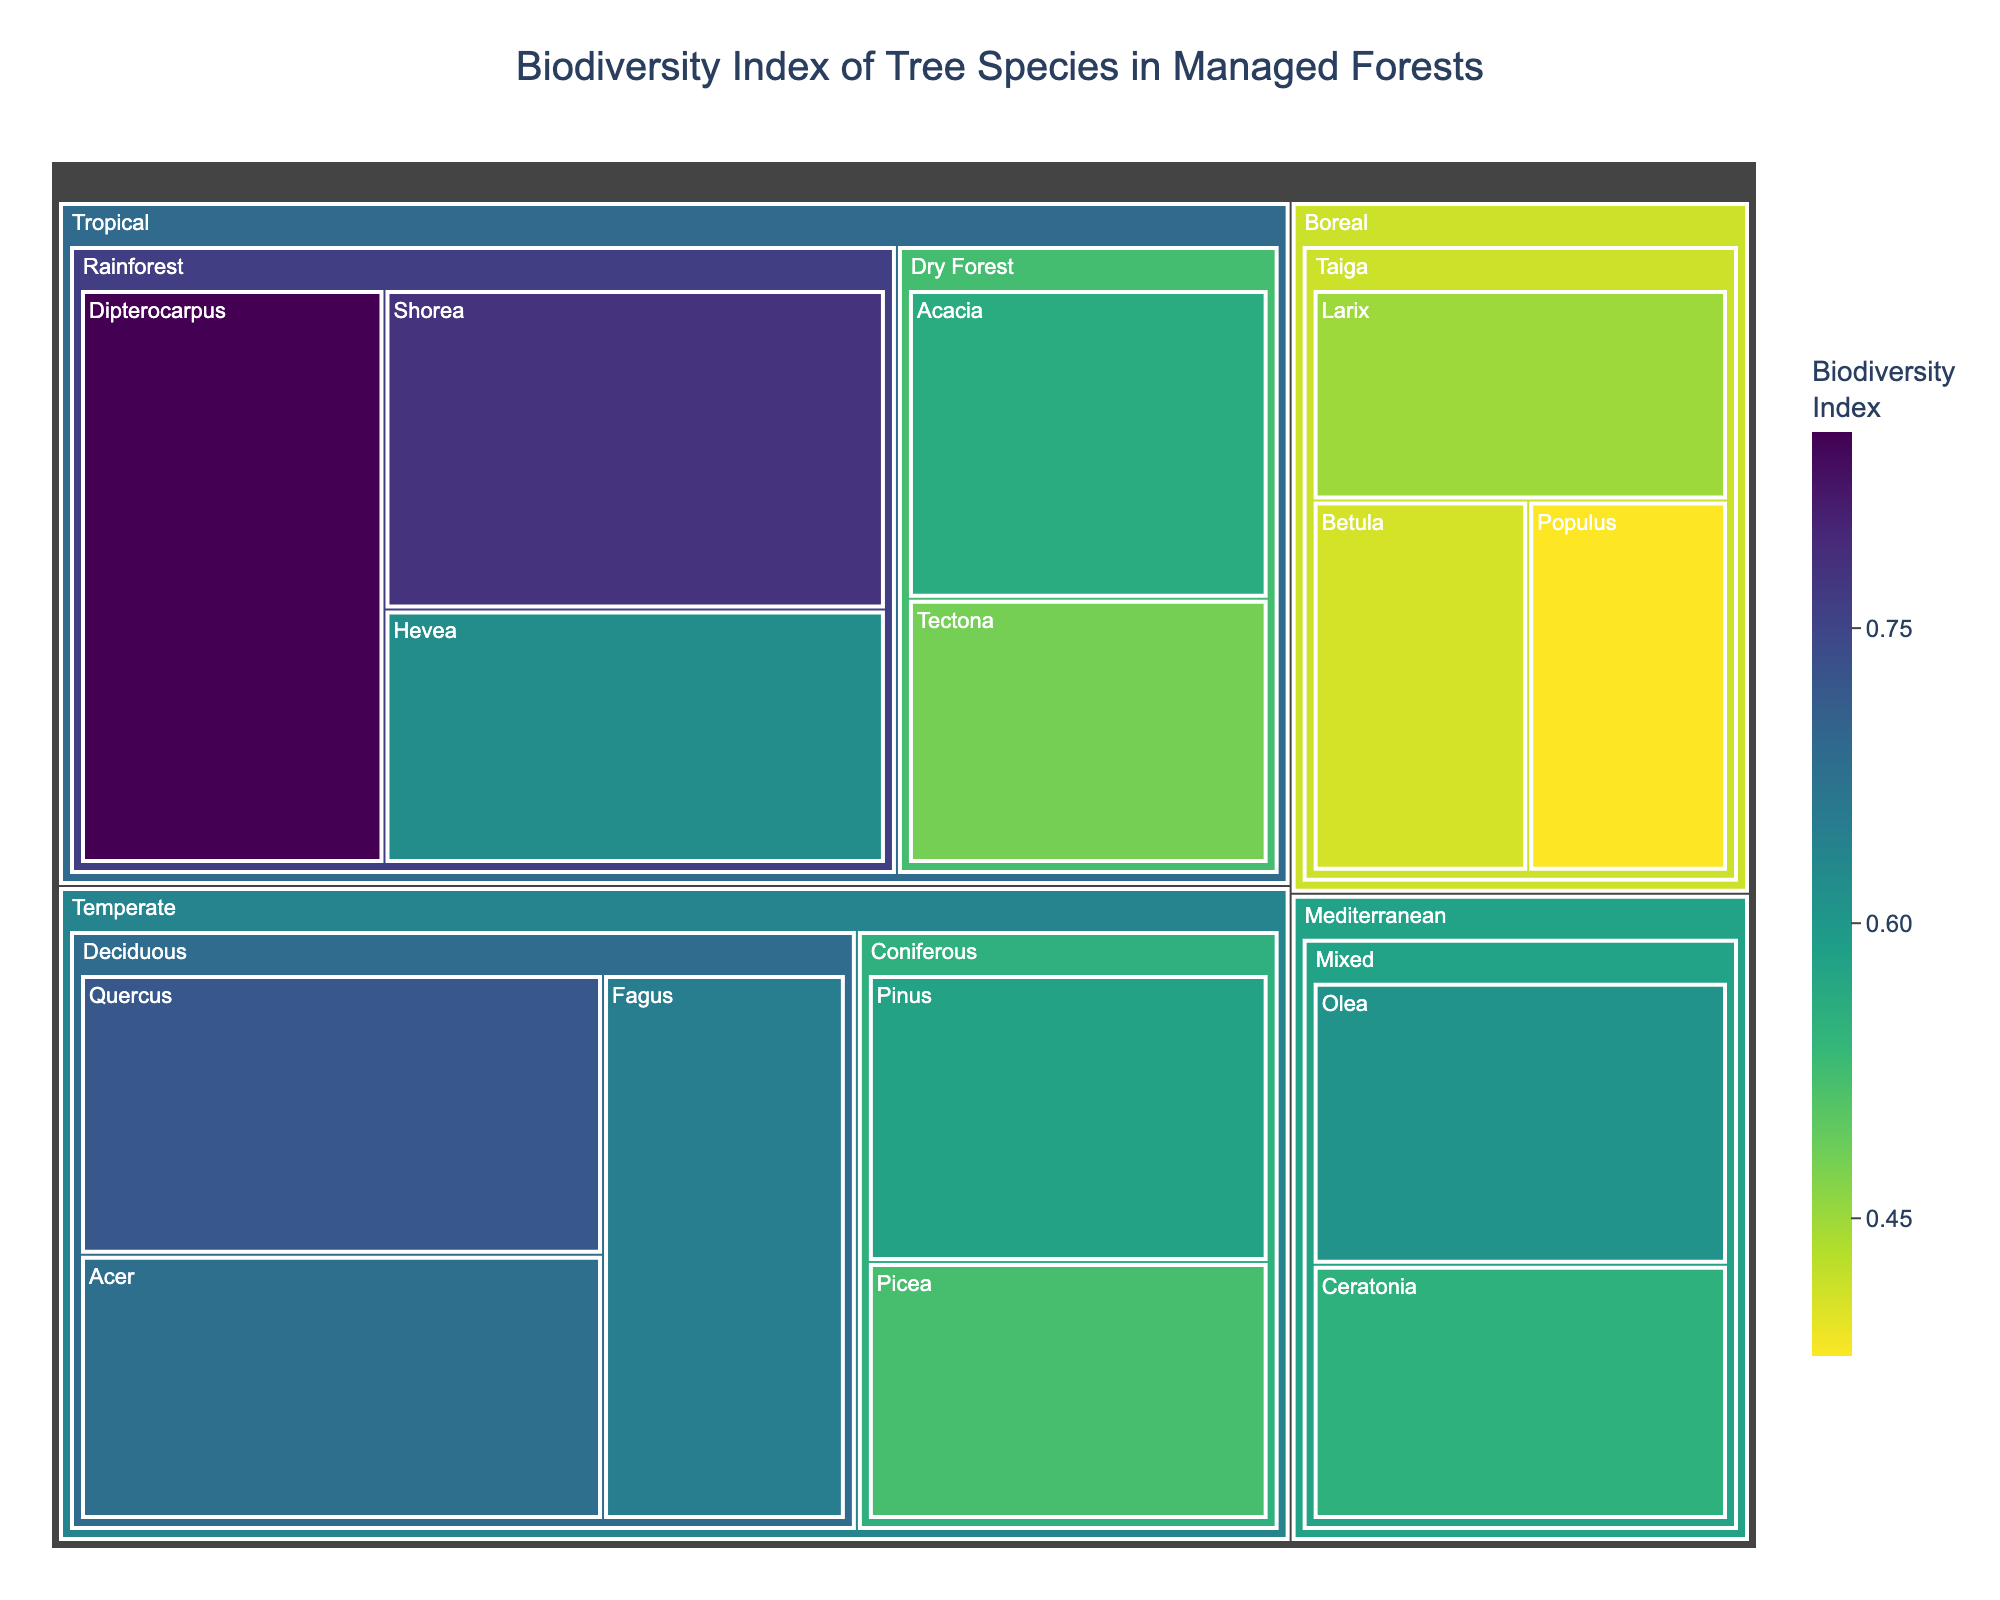what is the overall title of the figure? The overall title is usually found prominently at the top of the figure. In this plot, the title is centrally aligned at the top.
Answer: Biodiversity Index of Tree Species in Managed Forests Which climate zone has the highest biodiversity index tree species? Look for the tree species with the highest biodiviersity index and identify its climate zone, Dipterocarpus has the highest index at 0.85, which falls under the climate zone.
Answer: Tropical How many forest types are depicted under the temperate climate zone? The temperate climate zone can be identified, and under it, the forest types are Deciduous and Coniferous.
Answer: 2 Which tree species in the boreal zone has the lowest biodiversity index? By examining the tree species in the boreal zone, find the one with the lowest index. Populus with an index of 0.38 is the lowest in the boreal zone.
Answer: Populus What is the difference in the biodiversity index between Quercus and Fagus in temperate deciduous forests? Find the biodiversity index of Quercus (0.72) and Fagus (0.65) and compute their difference, 0.72 - 0.65.
Answer: 0.07 Which tree species has the highest biodiversity index among Mediterranean mixed forests? Identify and compare the biodiversity indices of Olea and Ceratonia, Olea has the highest index with a value of 0.61.
Answer: Olea Which climate zone has the smallest number of tree species represented? Compare the number of species listed under each climate zone; boreal taiga has three species listed, fewer than other zones.
Answer: Boreal How many tree species have a biodiversity index higher than 0.70? Check each tree species' biodiversity index and count those above 0.70. Only Dipterocarpus with 0.85 and Quercus with 0.72 meet this criterion.
Answer: 2 Which tree species has a higher biodiversity index: Acacia in Tropical Dry Forests or Pinus in Temperate Coniferous Forests? Compare the biodiversity indices of Acacia (0.56) and Pinus (0.58), Pinus has a higher index.
Answer: Pinus What is the average biodiversity index of tree species in the tropical rainforest? Sum the indices of Dipterocarpus (0.85), Shorea (0.78), and Hevea (0.62), then divide by 3: (0.85 + 0.78 + 0.62) / 3.
Answer: 0.75 